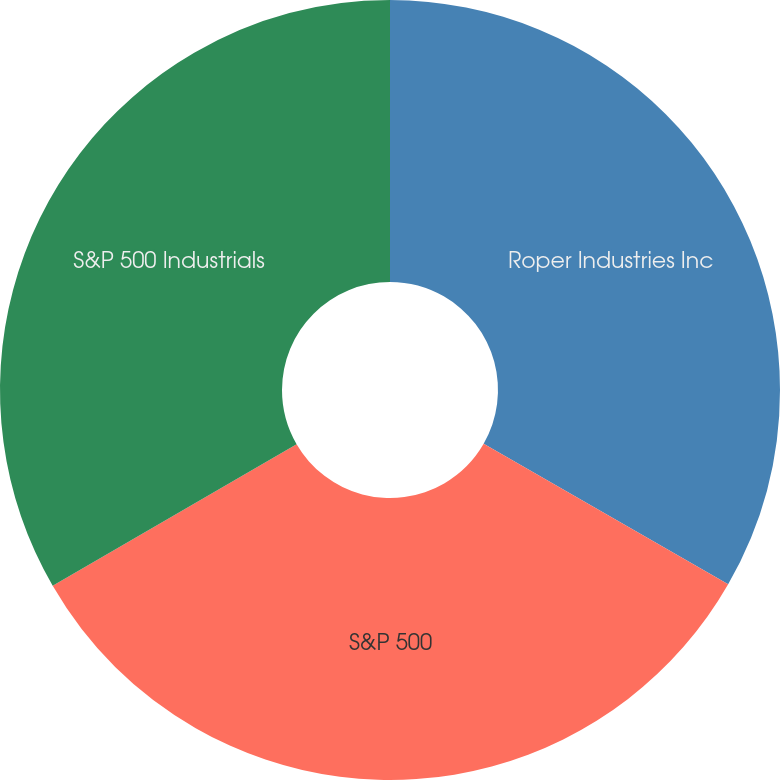<chart> <loc_0><loc_0><loc_500><loc_500><pie_chart><fcel>Roper Industries Inc<fcel>S&P 500<fcel>S&P 500 Industrials<nl><fcel>33.3%<fcel>33.33%<fcel>33.37%<nl></chart> 